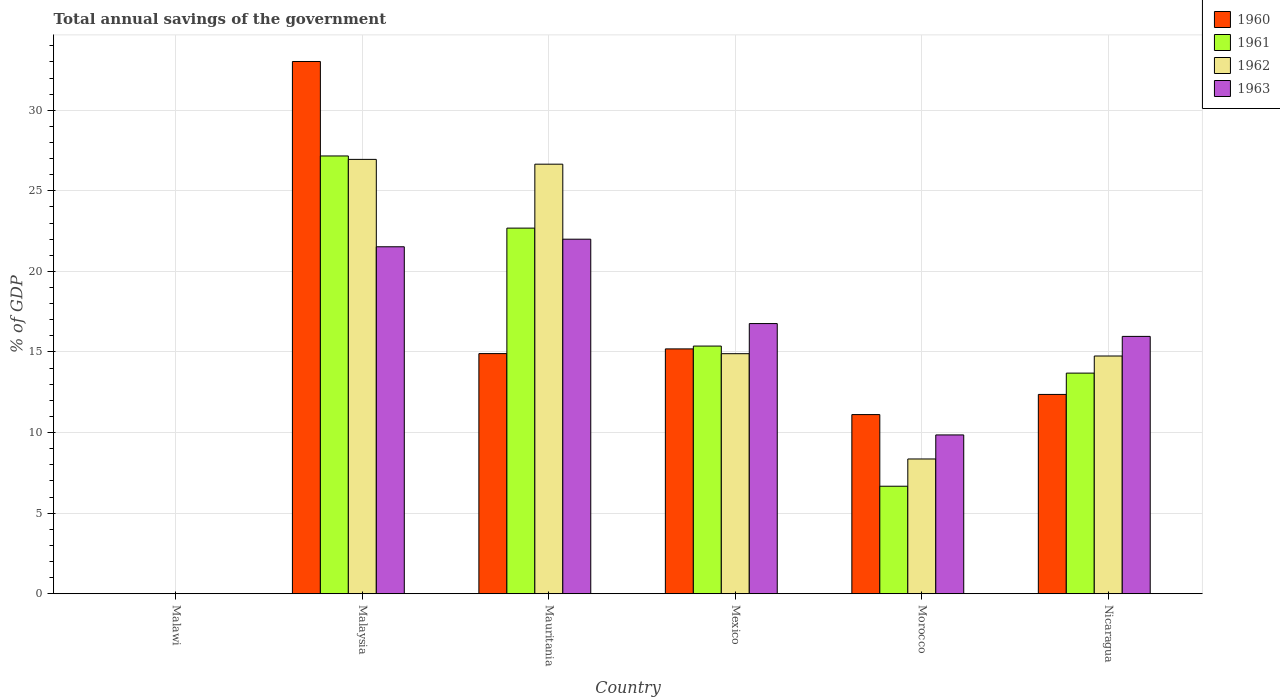How many different coloured bars are there?
Your answer should be very brief. 4. Are the number of bars per tick equal to the number of legend labels?
Give a very brief answer. No. Are the number of bars on each tick of the X-axis equal?
Keep it short and to the point. No. How many bars are there on the 2nd tick from the left?
Offer a terse response. 4. How many bars are there on the 4th tick from the right?
Your answer should be compact. 4. What is the label of the 3rd group of bars from the left?
Your answer should be very brief. Mauritania. What is the total annual savings of the government in 1963 in Morocco?
Your response must be concise. 9.85. Across all countries, what is the maximum total annual savings of the government in 1962?
Offer a terse response. 26.95. Across all countries, what is the minimum total annual savings of the government in 1962?
Provide a succinct answer. 0. In which country was the total annual savings of the government in 1963 maximum?
Your answer should be compact. Mauritania. What is the total total annual savings of the government in 1961 in the graph?
Your answer should be very brief. 85.58. What is the difference between the total annual savings of the government in 1963 in Malaysia and that in Morocco?
Keep it short and to the point. 11.67. What is the difference between the total annual savings of the government in 1963 in Morocco and the total annual savings of the government in 1961 in Malawi?
Give a very brief answer. 9.85. What is the average total annual savings of the government in 1962 per country?
Provide a succinct answer. 15.27. What is the difference between the total annual savings of the government of/in 1963 and total annual savings of the government of/in 1960 in Malaysia?
Ensure brevity in your answer.  -11.5. What is the ratio of the total annual savings of the government in 1963 in Mauritania to that in Morocco?
Your response must be concise. 2.23. Is the total annual savings of the government in 1960 in Mauritania less than that in Morocco?
Offer a terse response. No. Is the difference between the total annual savings of the government in 1963 in Mauritania and Morocco greater than the difference between the total annual savings of the government in 1960 in Mauritania and Morocco?
Make the answer very short. Yes. What is the difference between the highest and the second highest total annual savings of the government in 1960?
Offer a terse response. 18.13. What is the difference between the highest and the lowest total annual savings of the government in 1960?
Keep it short and to the point. 33.03. In how many countries, is the total annual savings of the government in 1963 greater than the average total annual savings of the government in 1963 taken over all countries?
Your answer should be very brief. 4. How many bars are there?
Your answer should be very brief. 20. What is the difference between two consecutive major ticks on the Y-axis?
Your answer should be very brief. 5. Are the values on the major ticks of Y-axis written in scientific E-notation?
Your answer should be compact. No. Does the graph contain grids?
Provide a succinct answer. Yes. Where does the legend appear in the graph?
Your answer should be very brief. Top right. How are the legend labels stacked?
Your answer should be compact. Vertical. What is the title of the graph?
Your response must be concise. Total annual savings of the government. Does "1976" appear as one of the legend labels in the graph?
Your response must be concise. No. What is the label or title of the Y-axis?
Give a very brief answer. % of GDP. What is the % of GDP of 1960 in Malaysia?
Your answer should be very brief. 33.03. What is the % of GDP in 1961 in Malaysia?
Make the answer very short. 27.16. What is the % of GDP in 1962 in Malaysia?
Give a very brief answer. 26.95. What is the % of GDP in 1963 in Malaysia?
Your answer should be compact. 21.53. What is the % of GDP in 1960 in Mauritania?
Make the answer very short. 14.9. What is the % of GDP in 1961 in Mauritania?
Keep it short and to the point. 22.69. What is the % of GDP of 1962 in Mauritania?
Your answer should be compact. 26.65. What is the % of GDP of 1963 in Mauritania?
Your answer should be very brief. 22. What is the % of GDP of 1960 in Mexico?
Give a very brief answer. 15.19. What is the % of GDP of 1961 in Mexico?
Provide a succinct answer. 15.37. What is the % of GDP of 1962 in Mexico?
Offer a terse response. 14.89. What is the % of GDP in 1963 in Mexico?
Your answer should be compact. 16.76. What is the % of GDP in 1960 in Morocco?
Your response must be concise. 11.12. What is the % of GDP of 1961 in Morocco?
Your answer should be very brief. 6.67. What is the % of GDP in 1962 in Morocco?
Your answer should be very brief. 8.36. What is the % of GDP of 1963 in Morocco?
Give a very brief answer. 9.85. What is the % of GDP in 1960 in Nicaragua?
Ensure brevity in your answer.  12.37. What is the % of GDP in 1961 in Nicaragua?
Give a very brief answer. 13.69. What is the % of GDP of 1962 in Nicaragua?
Make the answer very short. 14.75. What is the % of GDP of 1963 in Nicaragua?
Provide a short and direct response. 15.97. Across all countries, what is the maximum % of GDP in 1960?
Your answer should be very brief. 33.03. Across all countries, what is the maximum % of GDP of 1961?
Provide a short and direct response. 27.16. Across all countries, what is the maximum % of GDP of 1962?
Make the answer very short. 26.95. Across all countries, what is the maximum % of GDP in 1963?
Make the answer very short. 22. Across all countries, what is the minimum % of GDP in 1962?
Give a very brief answer. 0. What is the total % of GDP in 1960 in the graph?
Make the answer very short. 86.6. What is the total % of GDP of 1961 in the graph?
Your answer should be very brief. 85.58. What is the total % of GDP of 1962 in the graph?
Your response must be concise. 91.61. What is the total % of GDP of 1963 in the graph?
Offer a very short reply. 86.11. What is the difference between the % of GDP of 1960 in Malaysia and that in Mauritania?
Your answer should be compact. 18.13. What is the difference between the % of GDP of 1961 in Malaysia and that in Mauritania?
Make the answer very short. 4.48. What is the difference between the % of GDP of 1962 in Malaysia and that in Mauritania?
Your answer should be very brief. 0.3. What is the difference between the % of GDP in 1963 in Malaysia and that in Mauritania?
Ensure brevity in your answer.  -0.47. What is the difference between the % of GDP in 1960 in Malaysia and that in Mexico?
Give a very brief answer. 17.83. What is the difference between the % of GDP of 1961 in Malaysia and that in Mexico?
Give a very brief answer. 11.8. What is the difference between the % of GDP of 1962 in Malaysia and that in Mexico?
Offer a very short reply. 12.06. What is the difference between the % of GDP of 1963 in Malaysia and that in Mexico?
Your response must be concise. 4.77. What is the difference between the % of GDP of 1960 in Malaysia and that in Morocco?
Provide a short and direct response. 21.91. What is the difference between the % of GDP of 1961 in Malaysia and that in Morocco?
Keep it short and to the point. 20.49. What is the difference between the % of GDP in 1962 in Malaysia and that in Morocco?
Provide a short and direct response. 18.59. What is the difference between the % of GDP of 1963 in Malaysia and that in Morocco?
Ensure brevity in your answer.  11.68. What is the difference between the % of GDP of 1960 in Malaysia and that in Nicaragua?
Your answer should be compact. 20.66. What is the difference between the % of GDP in 1961 in Malaysia and that in Nicaragua?
Make the answer very short. 13.47. What is the difference between the % of GDP in 1962 in Malaysia and that in Nicaragua?
Offer a very short reply. 12.2. What is the difference between the % of GDP in 1963 in Malaysia and that in Nicaragua?
Ensure brevity in your answer.  5.56. What is the difference between the % of GDP of 1960 in Mauritania and that in Mexico?
Provide a short and direct response. -0.29. What is the difference between the % of GDP of 1961 in Mauritania and that in Mexico?
Give a very brief answer. 7.32. What is the difference between the % of GDP of 1962 in Mauritania and that in Mexico?
Make the answer very short. 11.76. What is the difference between the % of GDP in 1963 in Mauritania and that in Mexico?
Ensure brevity in your answer.  5.24. What is the difference between the % of GDP of 1960 in Mauritania and that in Morocco?
Ensure brevity in your answer.  3.78. What is the difference between the % of GDP in 1961 in Mauritania and that in Morocco?
Keep it short and to the point. 16.02. What is the difference between the % of GDP of 1962 in Mauritania and that in Morocco?
Ensure brevity in your answer.  18.29. What is the difference between the % of GDP in 1963 in Mauritania and that in Morocco?
Offer a very short reply. 12.14. What is the difference between the % of GDP in 1960 in Mauritania and that in Nicaragua?
Ensure brevity in your answer.  2.53. What is the difference between the % of GDP in 1961 in Mauritania and that in Nicaragua?
Ensure brevity in your answer.  9. What is the difference between the % of GDP in 1962 in Mauritania and that in Nicaragua?
Provide a short and direct response. 11.9. What is the difference between the % of GDP in 1963 in Mauritania and that in Nicaragua?
Your answer should be very brief. 6.03. What is the difference between the % of GDP of 1960 in Mexico and that in Morocco?
Provide a short and direct response. 4.08. What is the difference between the % of GDP in 1961 in Mexico and that in Morocco?
Offer a very short reply. 8.7. What is the difference between the % of GDP in 1962 in Mexico and that in Morocco?
Provide a succinct answer. 6.53. What is the difference between the % of GDP of 1963 in Mexico and that in Morocco?
Offer a terse response. 6.91. What is the difference between the % of GDP in 1960 in Mexico and that in Nicaragua?
Provide a short and direct response. 2.82. What is the difference between the % of GDP of 1961 in Mexico and that in Nicaragua?
Provide a succinct answer. 1.68. What is the difference between the % of GDP in 1962 in Mexico and that in Nicaragua?
Offer a very short reply. 0.14. What is the difference between the % of GDP in 1963 in Mexico and that in Nicaragua?
Ensure brevity in your answer.  0.8. What is the difference between the % of GDP in 1960 in Morocco and that in Nicaragua?
Make the answer very short. -1.25. What is the difference between the % of GDP in 1961 in Morocco and that in Nicaragua?
Offer a terse response. -7.02. What is the difference between the % of GDP of 1962 in Morocco and that in Nicaragua?
Give a very brief answer. -6.39. What is the difference between the % of GDP in 1963 in Morocco and that in Nicaragua?
Provide a short and direct response. -6.11. What is the difference between the % of GDP in 1960 in Malaysia and the % of GDP in 1961 in Mauritania?
Give a very brief answer. 10.34. What is the difference between the % of GDP in 1960 in Malaysia and the % of GDP in 1962 in Mauritania?
Offer a very short reply. 6.37. What is the difference between the % of GDP in 1960 in Malaysia and the % of GDP in 1963 in Mauritania?
Ensure brevity in your answer.  11.03. What is the difference between the % of GDP in 1961 in Malaysia and the % of GDP in 1962 in Mauritania?
Give a very brief answer. 0.51. What is the difference between the % of GDP in 1961 in Malaysia and the % of GDP in 1963 in Mauritania?
Your response must be concise. 5.17. What is the difference between the % of GDP of 1962 in Malaysia and the % of GDP of 1963 in Mauritania?
Offer a very short reply. 4.95. What is the difference between the % of GDP in 1960 in Malaysia and the % of GDP in 1961 in Mexico?
Provide a succinct answer. 17.66. What is the difference between the % of GDP of 1960 in Malaysia and the % of GDP of 1962 in Mexico?
Keep it short and to the point. 18.13. What is the difference between the % of GDP of 1960 in Malaysia and the % of GDP of 1963 in Mexico?
Provide a succinct answer. 16.26. What is the difference between the % of GDP in 1961 in Malaysia and the % of GDP in 1962 in Mexico?
Offer a very short reply. 12.27. What is the difference between the % of GDP of 1961 in Malaysia and the % of GDP of 1963 in Mexico?
Your response must be concise. 10.4. What is the difference between the % of GDP of 1962 in Malaysia and the % of GDP of 1963 in Mexico?
Offer a terse response. 10.19. What is the difference between the % of GDP in 1960 in Malaysia and the % of GDP in 1961 in Morocco?
Give a very brief answer. 26.35. What is the difference between the % of GDP in 1960 in Malaysia and the % of GDP in 1962 in Morocco?
Give a very brief answer. 24.66. What is the difference between the % of GDP in 1960 in Malaysia and the % of GDP in 1963 in Morocco?
Provide a succinct answer. 23.17. What is the difference between the % of GDP in 1961 in Malaysia and the % of GDP in 1962 in Morocco?
Keep it short and to the point. 18.8. What is the difference between the % of GDP of 1961 in Malaysia and the % of GDP of 1963 in Morocco?
Provide a short and direct response. 17.31. What is the difference between the % of GDP in 1962 in Malaysia and the % of GDP in 1963 in Morocco?
Provide a short and direct response. 17.1. What is the difference between the % of GDP of 1960 in Malaysia and the % of GDP of 1961 in Nicaragua?
Ensure brevity in your answer.  19.34. What is the difference between the % of GDP of 1960 in Malaysia and the % of GDP of 1962 in Nicaragua?
Keep it short and to the point. 18.27. What is the difference between the % of GDP in 1960 in Malaysia and the % of GDP in 1963 in Nicaragua?
Your answer should be very brief. 17.06. What is the difference between the % of GDP in 1961 in Malaysia and the % of GDP in 1962 in Nicaragua?
Your answer should be compact. 12.41. What is the difference between the % of GDP in 1961 in Malaysia and the % of GDP in 1963 in Nicaragua?
Provide a succinct answer. 11.2. What is the difference between the % of GDP of 1962 in Malaysia and the % of GDP of 1963 in Nicaragua?
Offer a very short reply. 10.98. What is the difference between the % of GDP in 1960 in Mauritania and the % of GDP in 1961 in Mexico?
Keep it short and to the point. -0.47. What is the difference between the % of GDP of 1960 in Mauritania and the % of GDP of 1962 in Mexico?
Your answer should be compact. 0.01. What is the difference between the % of GDP in 1960 in Mauritania and the % of GDP in 1963 in Mexico?
Ensure brevity in your answer.  -1.86. What is the difference between the % of GDP of 1961 in Mauritania and the % of GDP of 1962 in Mexico?
Give a very brief answer. 7.79. What is the difference between the % of GDP in 1961 in Mauritania and the % of GDP in 1963 in Mexico?
Give a very brief answer. 5.92. What is the difference between the % of GDP of 1962 in Mauritania and the % of GDP of 1963 in Mexico?
Ensure brevity in your answer.  9.89. What is the difference between the % of GDP of 1960 in Mauritania and the % of GDP of 1961 in Morocco?
Keep it short and to the point. 8.23. What is the difference between the % of GDP of 1960 in Mauritania and the % of GDP of 1962 in Morocco?
Give a very brief answer. 6.54. What is the difference between the % of GDP in 1960 in Mauritania and the % of GDP in 1963 in Morocco?
Ensure brevity in your answer.  5.05. What is the difference between the % of GDP of 1961 in Mauritania and the % of GDP of 1962 in Morocco?
Keep it short and to the point. 14.32. What is the difference between the % of GDP of 1961 in Mauritania and the % of GDP of 1963 in Morocco?
Offer a very short reply. 12.83. What is the difference between the % of GDP of 1962 in Mauritania and the % of GDP of 1963 in Morocco?
Ensure brevity in your answer.  16.8. What is the difference between the % of GDP of 1960 in Mauritania and the % of GDP of 1961 in Nicaragua?
Your answer should be very brief. 1.21. What is the difference between the % of GDP in 1960 in Mauritania and the % of GDP in 1962 in Nicaragua?
Provide a succinct answer. 0.15. What is the difference between the % of GDP in 1960 in Mauritania and the % of GDP in 1963 in Nicaragua?
Offer a terse response. -1.07. What is the difference between the % of GDP in 1961 in Mauritania and the % of GDP in 1962 in Nicaragua?
Your response must be concise. 7.93. What is the difference between the % of GDP in 1961 in Mauritania and the % of GDP in 1963 in Nicaragua?
Provide a short and direct response. 6.72. What is the difference between the % of GDP in 1962 in Mauritania and the % of GDP in 1963 in Nicaragua?
Give a very brief answer. 10.69. What is the difference between the % of GDP in 1960 in Mexico and the % of GDP in 1961 in Morocco?
Your answer should be compact. 8.52. What is the difference between the % of GDP in 1960 in Mexico and the % of GDP in 1962 in Morocco?
Your answer should be very brief. 6.83. What is the difference between the % of GDP of 1960 in Mexico and the % of GDP of 1963 in Morocco?
Your answer should be very brief. 5.34. What is the difference between the % of GDP in 1961 in Mexico and the % of GDP in 1962 in Morocco?
Give a very brief answer. 7.01. What is the difference between the % of GDP in 1961 in Mexico and the % of GDP in 1963 in Morocco?
Make the answer very short. 5.51. What is the difference between the % of GDP of 1962 in Mexico and the % of GDP of 1963 in Morocco?
Offer a terse response. 5.04. What is the difference between the % of GDP in 1960 in Mexico and the % of GDP in 1961 in Nicaragua?
Give a very brief answer. 1.5. What is the difference between the % of GDP of 1960 in Mexico and the % of GDP of 1962 in Nicaragua?
Your response must be concise. 0.44. What is the difference between the % of GDP in 1960 in Mexico and the % of GDP in 1963 in Nicaragua?
Offer a terse response. -0.78. What is the difference between the % of GDP in 1961 in Mexico and the % of GDP in 1962 in Nicaragua?
Offer a very short reply. 0.62. What is the difference between the % of GDP of 1961 in Mexico and the % of GDP of 1963 in Nicaragua?
Make the answer very short. -0.6. What is the difference between the % of GDP of 1962 in Mexico and the % of GDP of 1963 in Nicaragua?
Give a very brief answer. -1.07. What is the difference between the % of GDP in 1960 in Morocco and the % of GDP in 1961 in Nicaragua?
Give a very brief answer. -2.57. What is the difference between the % of GDP of 1960 in Morocco and the % of GDP of 1962 in Nicaragua?
Your answer should be compact. -3.63. What is the difference between the % of GDP in 1960 in Morocco and the % of GDP in 1963 in Nicaragua?
Your answer should be very brief. -4.85. What is the difference between the % of GDP of 1961 in Morocco and the % of GDP of 1962 in Nicaragua?
Offer a terse response. -8.08. What is the difference between the % of GDP of 1961 in Morocco and the % of GDP of 1963 in Nicaragua?
Your answer should be compact. -9.3. What is the difference between the % of GDP in 1962 in Morocco and the % of GDP in 1963 in Nicaragua?
Your answer should be compact. -7.61. What is the average % of GDP in 1960 per country?
Your response must be concise. 14.43. What is the average % of GDP in 1961 per country?
Provide a succinct answer. 14.26. What is the average % of GDP of 1962 per country?
Provide a succinct answer. 15.27. What is the average % of GDP in 1963 per country?
Ensure brevity in your answer.  14.35. What is the difference between the % of GDP of 1960 and % of GDP of 1961 in Malaysia?
Keep it short and to the point. 5.86. What is the difference between the % of GDP of 1960 and % of GDP of 1962 in Malaysia?
Your response must be concise. 6.07. What is the difference between the % of GDP in 1960 and % of GDP in 1963 in Malaysia?
Give a very brief answer. 11.5. What is the difference between the % of GDP in 1961 and % of GDP in 1962 in Malaysia?
Keep it short and to the point. 0.21. What is the difference between the % of GDP in 1961 and % of GDP in 1963 in Malaysia?
Keep it short and to the point. 5.63. What is the difference between the % of GDP in 1962 and % of GDP in 1963 in Malaysia?
Give a very brief answer. 5.42. What is the difference between the % of GDP of 1960 and % of GDP of 1961 in Mauritania?
Provide a short and direct response. -7.79. What is the difference between the % of GDP in 1960 and % of GDP in 1962 in Mauritania?
Offer a terse response. -11.75. What is the difference between the % of GDP in 1960 and % of GDP in 1963 in Mauritania?
Your answer should be compact. -7.1. What is the difference between the % of GDP in 1961 and % of GDP in 1962 in Mauritania?
Offer a terse response. -3.97. What is the difference between the % of GDP of 1961 and % of GDP of 1963 in Mauritania?
Provide a succinct answer. 0.69. What is the difference between the % of GDP in 1962 and % of GDP in 1963 in Mauritania?
Ensure brevity in your answer.  4.66. What is the difference between the % of GDP of 1960 and % of GDP of 1961 in Mexico?
Your response must be concise. -0.18. What is the difference between the % of GDP in 1960 and % of GDP in 1962 in Mexico?
Provide a short and direct response. 0.3. What is the difference between the % of GDP of 1960 and % of GDP of 1963 in Mexico?
Provide a short and direct response. -1.57. What is the difference between the % of GDP in 1961 and % of GDP in 1962 in Mexico?
Provide a succinct answer. 0.47. What is the difference between the % of GDP in 1961 and % of GDP in 1963 in Mexico?
Make the answer very short. -1.4. What is the difference between the % of GDP in 1962 and % of GDP in 1963 in Mexico?
Provide a short and direct response. -1.87. What is the difference between the % of GDP of 1960 and % of GDP of 1961 in Morocco?
Your answer should be very brief. 4.45. What is the difference between the % of GDP of 1960 and % of GDP of 1962 in Morocco?
Give a very brief answer. 2.75. What is the difference between the % of GDP in 1960 and % of GDP in 1963 in Morocco?
Give a very brief answer. 1.26. What is the difference between the % of GDP of 1961 and % of GDP of 1962 in Morocco?
Your response must be concise. -1.69. What is the difference between the % of GDP in 1961 and % of GDP in 1963 in Morocco?
Provide a succinct answer. -3.18. What is the difference between the % of GDP of 1962 and % of GDP of 1963 in Morocco?
Keep it short and to the point. -1.49. What is the difference between the % of GDP of 1960 and % of GDP of 1961 in Nicaragua?
Your response must be concise. -1.32. What is the difference between the % of GDP in 1960 and % of GDP in 1962 in Nicaragua?
Your response must be concise. -2.38. What is the difference between the % of GDP in 1960 and % of GDP in 1963 in Nicaragua?
Give a very brief answer. -3.6. What is the difference between the % of GDP of 1961 and % of GDP of 1962 in Nicaragua?
Provide a succinct answer. -1.06. What is the difference between the % of GDP of 1961 and % of GDP of 1963 in Nicaragua?
Your answer should be very brief. -2.28. What is the difference between the % of GDP in 1962 and % of GDP in 1963 in Nicaragua?
Give a very brief answer. -1.22. What is the ratio of the % of GDP in 1960 in Malaysia to that in Mauritania?
Make the answer very short. 2.22. What is the ratio of the % of GDP in 1961 in Malaysia to that in Mauritania?
Provide a short and direct response. 1.2. What is the ratio of the % of GDP in 1962 in Malaysia to that in Mauritania?
Offer a very short reply. 1.01. What is the ratio of the % of GDP in 1963 in Malaysia to that in Mauritania?
Offer a very short reply. 0.98. What is the ratio of the % of GDP in 1960 in Malaysia to that in Mexico?
Provide a short and direct response. 2.17. What is the ratio of the % of GDP in 1961 in Malaysia to that in Mexico?
Provide a short and direct response. 1.77. What is the ratio of the % of GDP of 1962 in Malaysia to that in Mexico?
Keep it short and to the point. 1.81. What is the ratio of the % of GDP in 1963 in Malaysia to that in Mexico?
Keep it short and to the point. 1.28. What is the ratio of the % of GDP of 1960 in Malaysia to that in Morocco?
Offer a very short reply. 2.97. What is the ratio of the % of GDP in 1961 in Malaysia to that in Morocco?
Provide a short and direct response. 4.07. What is the ratio of the % of GDP of 1962 in Malaysia to that in Morocco?
Give a very brief answer. 3.22. What is the ratio of the % of GDP in 1963 in Malaysia to that in Morocco?
Your answer should be very brief. 2.18. What is the ratio of the % of GDP in 1960 in Malaysia to that in Nicaragua?
Provide a succinct answer. 2.67. What is the ratio of the % of GDP of 1961 in Malaysia to that in Nicaragua?
Make the answer very short. 1.98. What is the ratio of the % of GDP in 1962 in Malaysia to that in Nicaragua?
Provide a short and direct response. 1.83. What is the ratio of the % of GDP of 1963 in Malaysia to that in Nicaragua?
Your answer should be compact. 1.35. What is the ratio of the % of GDP in 1960 in Mauritania to that in Mexico?
Your response must be concise. 0.98. What is the ratio of the % of GDP in 1961 in Mauritania to that in Mexico?
Your answer should be very brief. 1.48. What is the ratio of the % of GDP in 1962 in Mauritania to that in Mexico?
Offer a very short reply. 1.79. What is the ratio of the % of GDP of 1963 in Mauritania to that in Mexico?
Keep it short and to the point. 1.31. What is the ratio of the % of GDP of 1960 in Mauritania to that in Morocco?
Your answer should be very brief. 1.34. What is the ratio of the % of GDP in 1961 in Mauritania to that in Morocco?
Provide a succinct answer. 3.4. What is the ratio of the % of GDP of 1962 in Mauritania to that in Morocco?
Make the answer very short. 3.19. What is the ratio of the % of GDP of 1963 in Mauritania to that in Morocco?
Give a very brief answer. 2.23. What is the ratio of the % of GDP in 1960 in Mauritania to that in Nicaragua?
Your answer should be very brief. 1.2. What is the ratio of the % of GDP in 1961 in Mauritania to that in Nicaragua?
Offer a very short reply. 1.66. What is the ratio of the % of GDP of 1962 in Mauritania to that in Nicaragua?
Your answer should be very brief. 1.81. What is the ratio of the % of GDP in 1963 in Mauritania to that in Nicaragua?
Offer a terse response. 1.38. What is the ratio of the % of GDP in 1960 in Mexico to that in Morocco?
Provide a succinct answer. 1.37. What is the ratio of the % of GDP in 1961 in Mexico to that in Morocco?
Offer a terse response. 2.3. What is the ratio of the % of GDP in 1962 in Mexico to that in Morocco?
Give a very brief answer. 1.78. What is the ratio of the % of GDP of 1963 in Mexico to that in Morocco?
Make the answer very short. 1.7. What is the ratio of the % of GDP of 1960 in Mexico to that in Nicaragua?
Your answer should be very brief. 1.23. What is the ratio of the % of GDP in 1961 in Mexico to that in Nicaragua?
Keep it short and to the point. 1.12. What is the ratio of the % of GDP of 1962 in Mexico to that in Nicaragua?
Provide a succinct answer. 1.01. What is the ratio of the % of GDP of 1963 in Mexico to that in Nicaragua?
Your response must be concise. 1.05. What is the ratio of the % of GDP in 1960 in Morocco to that in Nicaragua?
Ensure brevity in your answer.  0.9. What is the ratio of the % of GDP of 1961 in Morocco to that in Nicaragua?
Your response must be concise. 0.49. What is the ratio of the % of GDP in 1962 in Morocco to that in Nicaragua?
Provide a succinct answer. 0.57. What is the ratio of the % of GDP of 1963 in Morocco to that in Nicaragua?
Give a very brief answer. 0.62. What is the difference between the highest and the second highest % of GDP of 1960?
Your response must be concise. 17.83. What is the difference between the highest and the second highest % of GDP of 1961?
Keep it short and to the point. 4.48. What is the difference between the highest and the second highest % of GDP of 1962?
Ensure brevity in your answer.  0.3. What is the difference between the highest and the second highest % of GDP in 1963?
Your answer should be compact. 0.47. What is the difference between the highest and the lowest % of GDP in 1960?
Give a very brief answer. 33.03. What is the difference between the highest and the lowest % of GDP of 1961?
Ensure brevity in your answer.  27.16. What is the difference between the highest and the lowest % of GDP of 1962?
Offer a terse response. 26.95. What is the difference between the highest and the lowest % of GDP of 1963?
Ensure brevity in your answer.  22. 